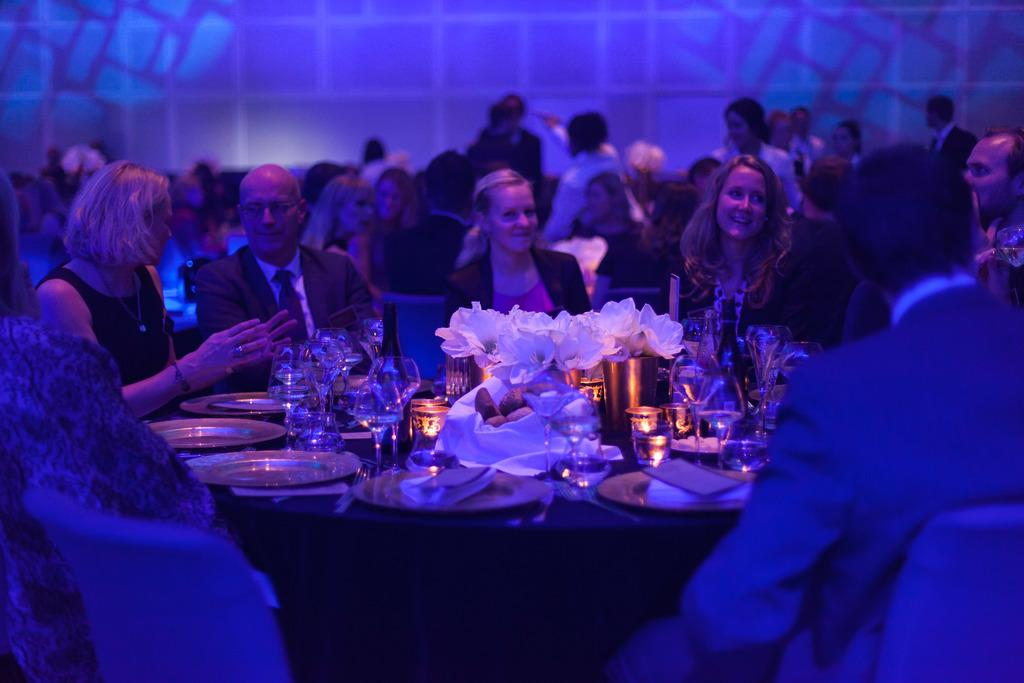What is happening in the image? There are people sitting in front of a table and people standing behind the table. What can be seen on the table? There are objects placed on the table. What type of skate is being used by the people in the image? There is no skate present in the image. How are the people's muscles being utilized in the image? The image does not show any specific use of muscles by the people. 